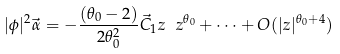<formula> <loc_0><loc_0><loc_500><loc_500>| \phi | ^ { 2 } \vec { \alpha } = - \frac { ( \theta _ { 0 } - 2 ) } { 2 \theta _ { 0 } ^ { 2 } } \vec { C } _ { 1 } z \ z ^ { \theta _ { 0 } } + \cdots + O ( | z | ^ { \theta _ { 0 } + 4 } )</formula> 